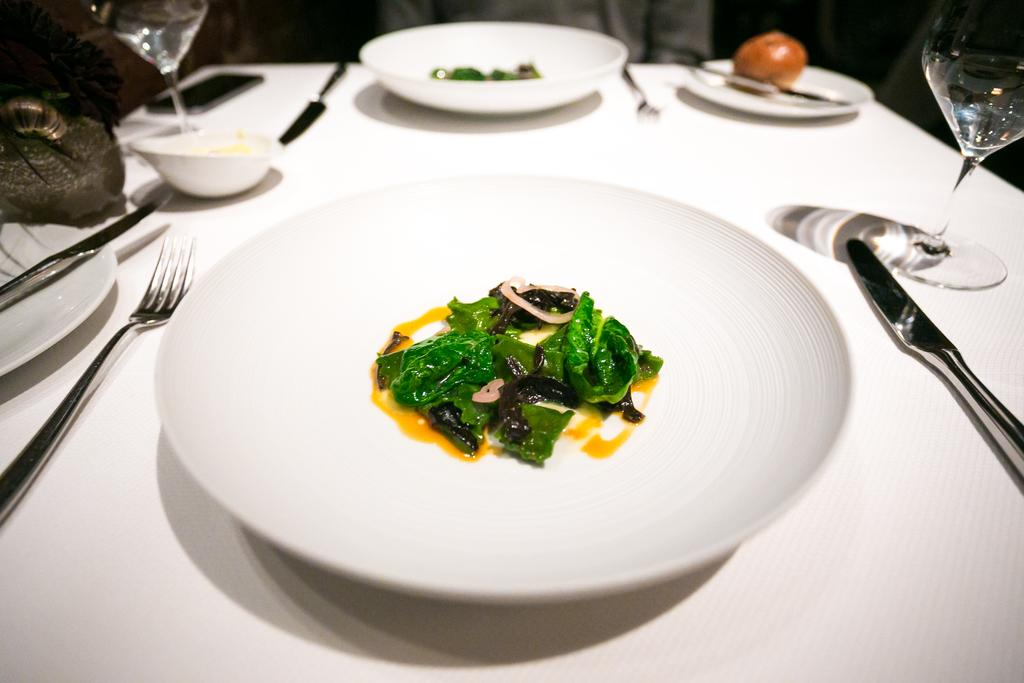What types of food items can be seen in the image? There are food items on plates and in a bowl in the image. What beverage is being served in the glasses in the image? The glasses contain water in the image. What utensils are present on the table in the image? There are knives and forks on the table in the image. Can you describe the background of the image? The background of the image is blurry. How many tins can be seen in the image? There are no tins present in the image. What type of soda is being served in the glasses in the image? The glasses contain water, not soda, in the image. 